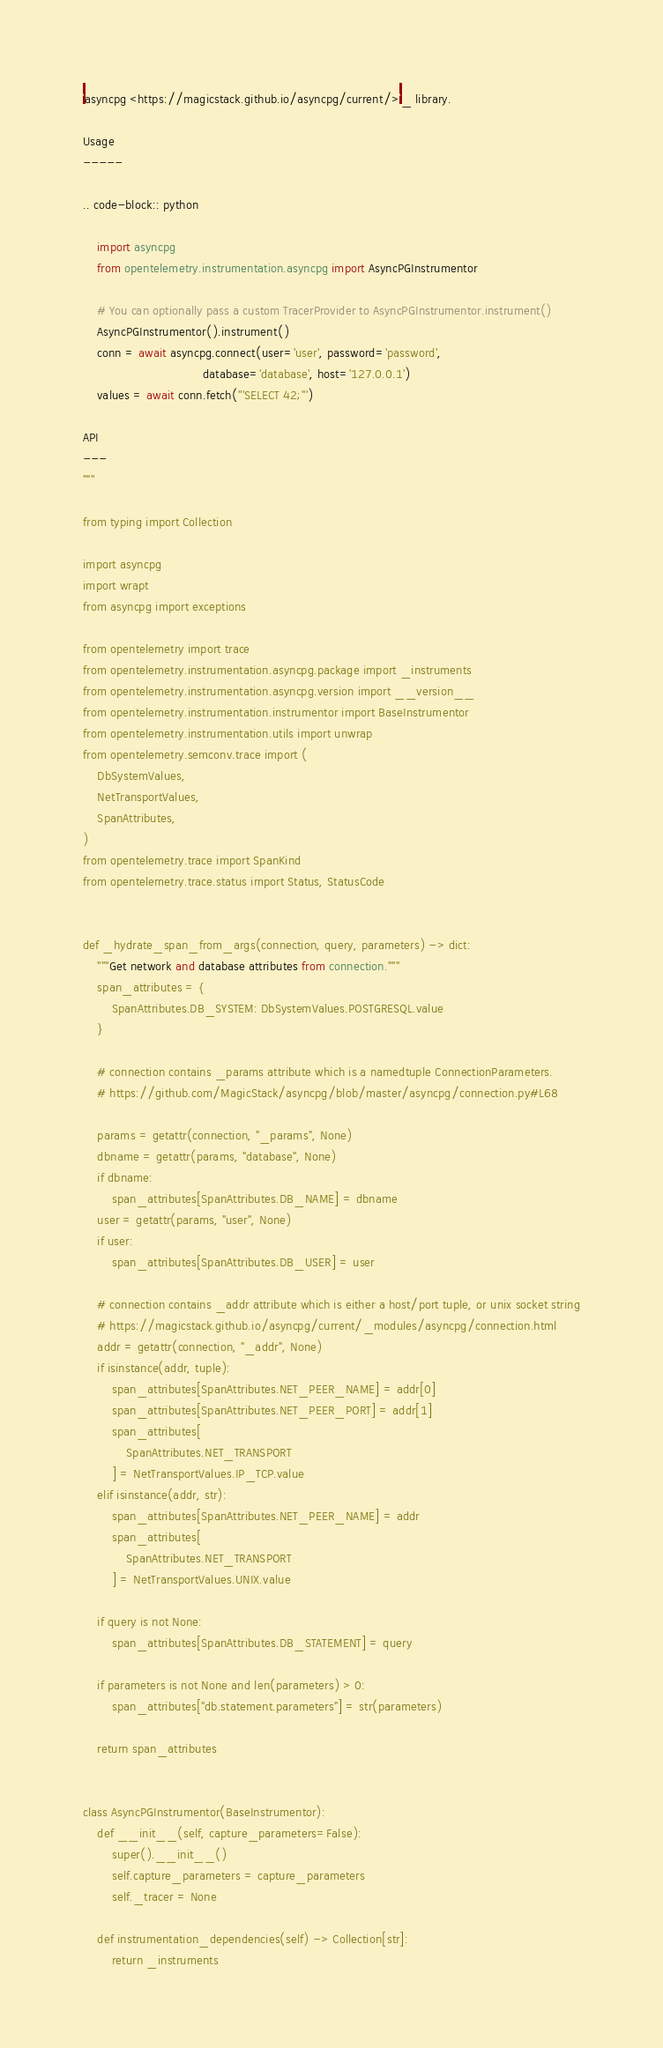Convert code to text. <code><loc_0><loc_0><loc_500><loc_500><_Python_>`asyncpg <https://magicstack.github.io/asyncpg/current/>`_ library.

Usage
-----

.. code-block:: python

    import asyncpg
    from opentelemetry.instrumentation.asyncpg import AsyncPGInstrumentor

    # You can optionally pass a custom TracerProvider to AsyncPGInstrumentor.instrument()
    AsyncPGInstrumentor().instrument()
    conn = await asyncpg.connect(user='user', password='password',
                                 database='database', host='127.0.0.1')
    values = await conn.fetch('''SELECT 42;''')

API
---
"""

from typing import Collection

import asyncpg
import wrapt
from asyncpg import exceptions

from opentelemetry import trace
from opentelemetry.instrumentation.asyncpg.package import _instruments
from opentelemetry.instrumentation.asyncpg.version import __version__
from opentelemetry.instrumentation.instrumentor import BaseInstrumentor
from opentelemetry.instrumentation.utils import unwrap
from opentelemetry.semconv.trace import (
    DbSystemValues,
    NetTransportValues,
    SpanAttributes,
)
from opentelemetry.trace import SpanKind
from opentelemetry.trace.status import Status, StatusCode


def _hydrate_span_from_args(connection, query, parameters) -> dict:
    """Get network and database attributes from connection."""
    span_attributes = {
        SpanAttributes.DB_SYSTEM: DbSystemValues.POSTGRESQL.value
    }

    # connection contains _params attribute which is a namedtuple ConnectionParameters.
    # https://github.com/MagicStack/asyncpg/blob/master/asyncpg/connection.py#L68

    params = getattr(connection, "_params", None)
    dbname = getattr(params, "database", None)
    if dbname:
        span_attributes[SpanAttributes.DB_NAME] = dbname
    user = getattr(params, "user", None)
    if user:
        span_attributes[SpanAttributes.DB_USER] = user

    # connection contains _addr attribute which is either a host/port tuple, or unix socket string
    # https://magicstack.github.io/asyncpg/current/_modules/asyncpg/connection.html
    addr = getattr(connection, "_addr", None)
    if isinstance(addr, tuple):
        span_attributes[SpanAttributes.NET_PEER_NAME] = addr[0]
        span_attributes[SpanAttributes.NET_PEER_PORT] = addr[1]
        span_attributes[
            SpanAttributes.NET_TRANSPORT
        ] = NetTransportValues.IP_TCP.value
    elif isinstance(addr, str):
        span_attributes[SpanAttributes.NET_PEER_NAME] = addr
        span_attributes[
            SpanAttributes.NET_TRANSPORT
        ] = NetTransportValues.UNIX.value

    if query is not None:
        span_attributes[SpanAttributes.DB_STATEMENT] = query

    if parameters is not None and len(parameters) > 0:
        span_attributes["db.statement.parameters"] = str(parameters)

    return span_attributes


class AsyncPGInstrumentor(BaseInstrumentor):
    def __init__(self, capture_parameters=False):
        super().__init__()
        self.capture_parameters = capture_parameters
        self._tracer = None

    def instrumentation_dependencies(self) -> Collection[str]:
        return _instruments
</code> 